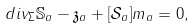Convert formula to latex. <formula><loc_0><loc_0><loc_500><loc_500>d i v _ { \Sigma } \mathbb { S } _ { a } - \mathfrak { z } _ { a } + [ \mathcal { S } _ { a } ] m _ { a } = 0 ,</formula> 